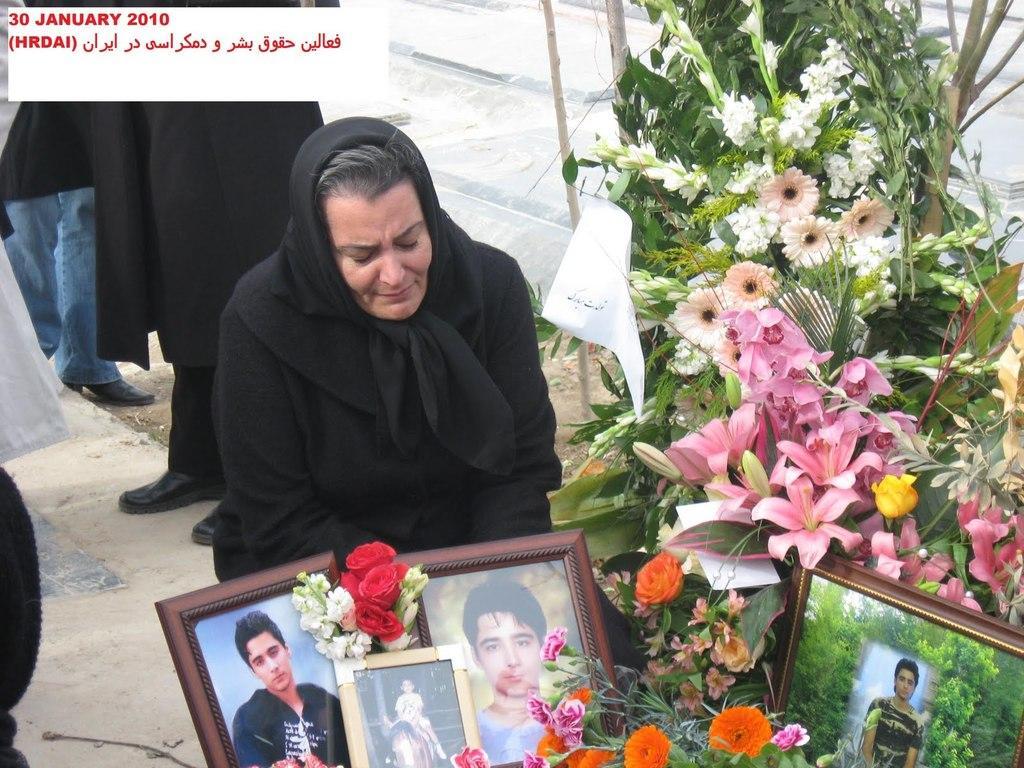In one or two sentences, can you explain what this image depicts? In this image we can see persons standing and a woman sitting on the ground before a flower bouquet and photo frames. 